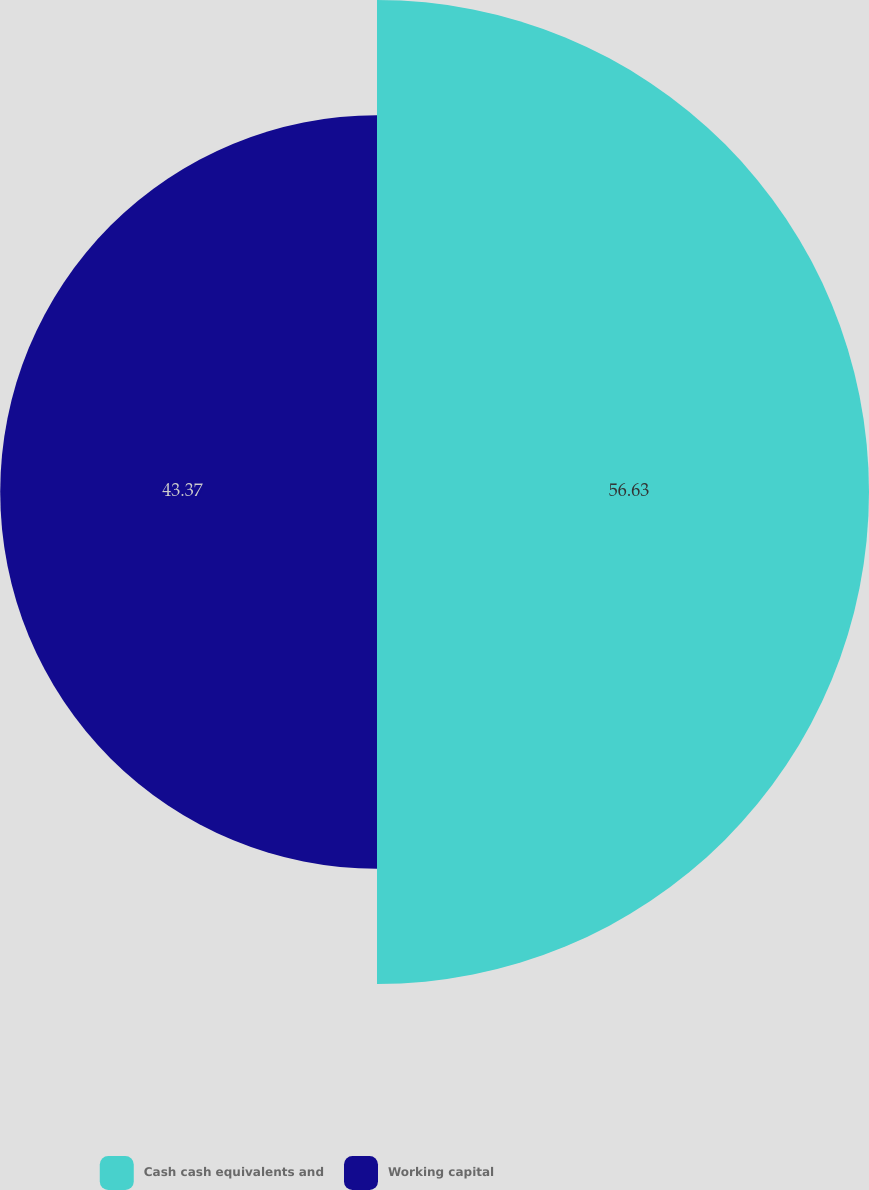<chart> <loc_0><loc_0><loc_500><loc_500><pie_chart><fcel>Cash cash equivalents and<fcel>Working capital<nl><fcel>56.63%<fcel>43.37%<nl></chart> 